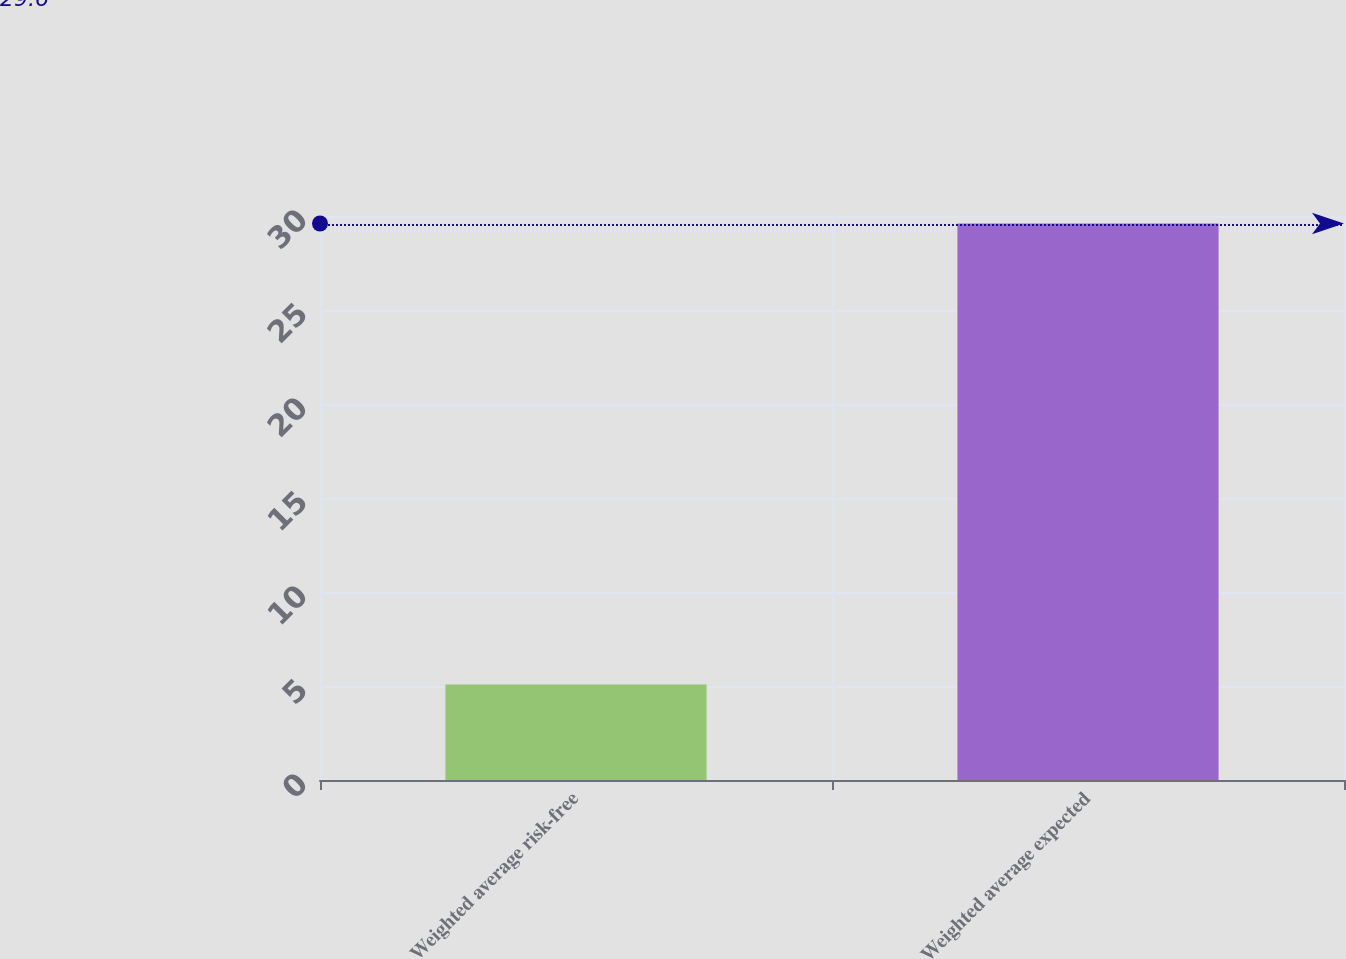Convert chart. <chart><loc_0><loc_0><loc_500><loc_500><bar_chart><fcel>Weighted average risk-free<fcel>Weighted average expected<nl><fcel>5.08<fcel>29.6<nl></chart> 